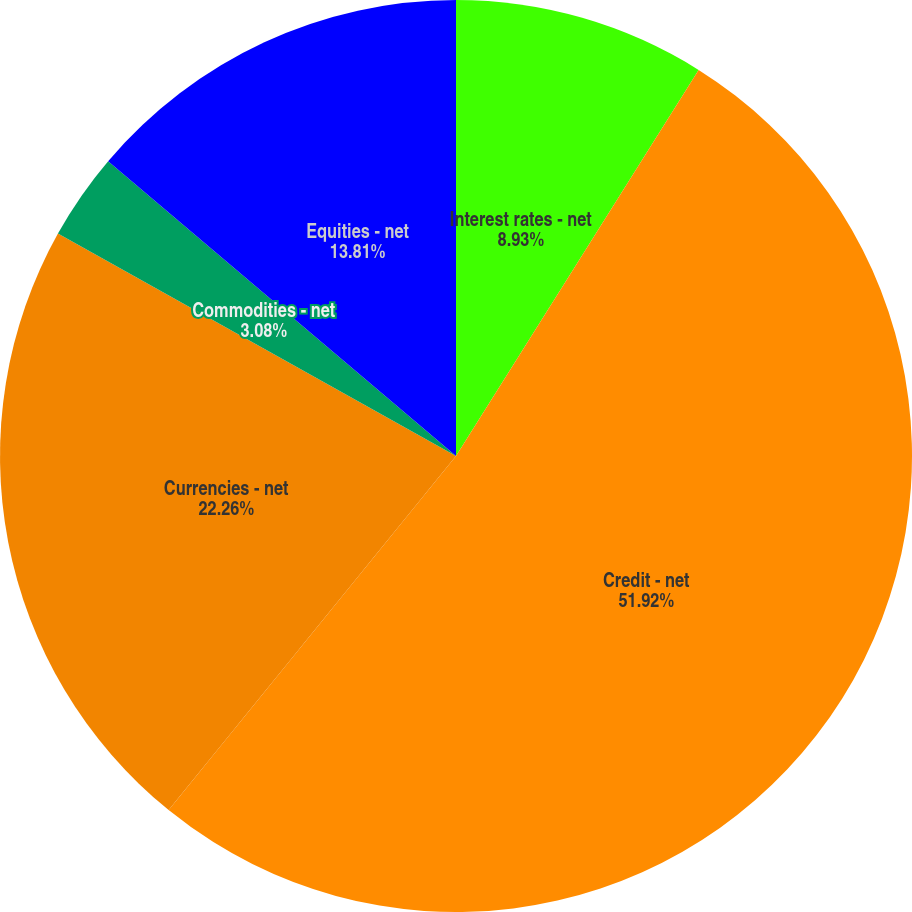Convert chart to OTSL. <chart><loc_0><loc_0><loc_500><loc_500><pie_chart><fcel>Interest rates - net<fcel>Credit - net<fcel>Currencies - net<fcel>Commodities - net<fcel>Equities - net<nl><fcel>8.93%<fcel>51.92%<fcel>22.26%<fcel>3.08%<fcel>13.81%<nl></chart> 